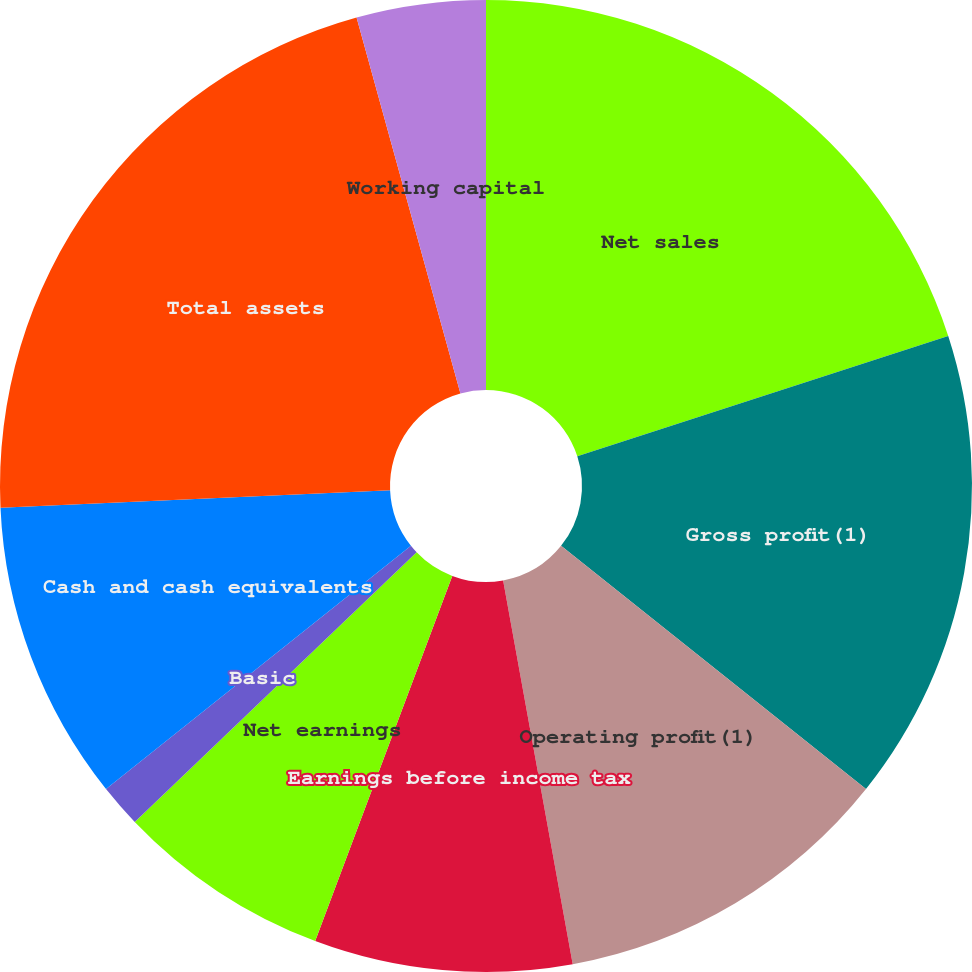Convert chart to OTSL. <chart><loc_0><loc_0><loc_500><loc_500><pie_chart><fcel>Net sales<fcel>Gross profit(1)<fcel>Operating profit(1)<fcel>Earnings before income tax<fcel>Net earnings<fcel>Basic<fcel>Diluted<fcel>Cash and cash equivalents<fcel>Total assets<fcel>Working capital<nl><fcel>20.0%<fcel>15.71%<fcel>11.43%<fcel>8.57%<fcel>7.14%<fcel>1.43%<fcel>0.0%<fcel>10.0%<fcel>21.42%<fcel>4.29%<nl></chart> 